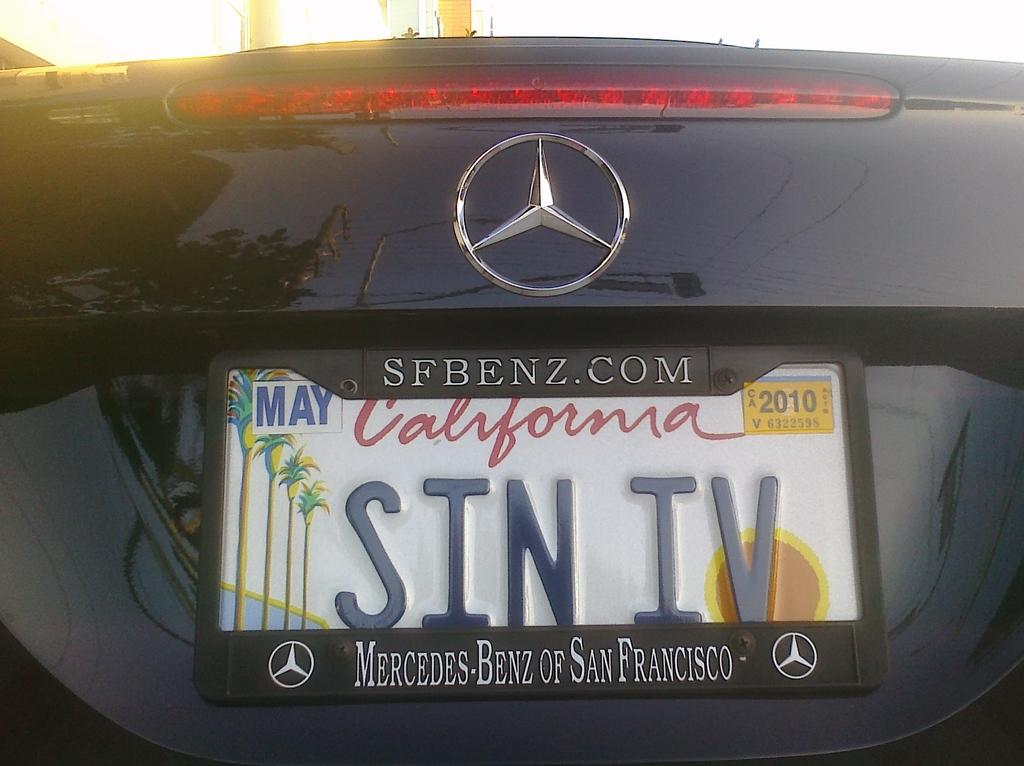<image>
Create a compact narrative representing the image presented. The rear end of a Mercedes Benz with a California license plate numbered SIN IV. 